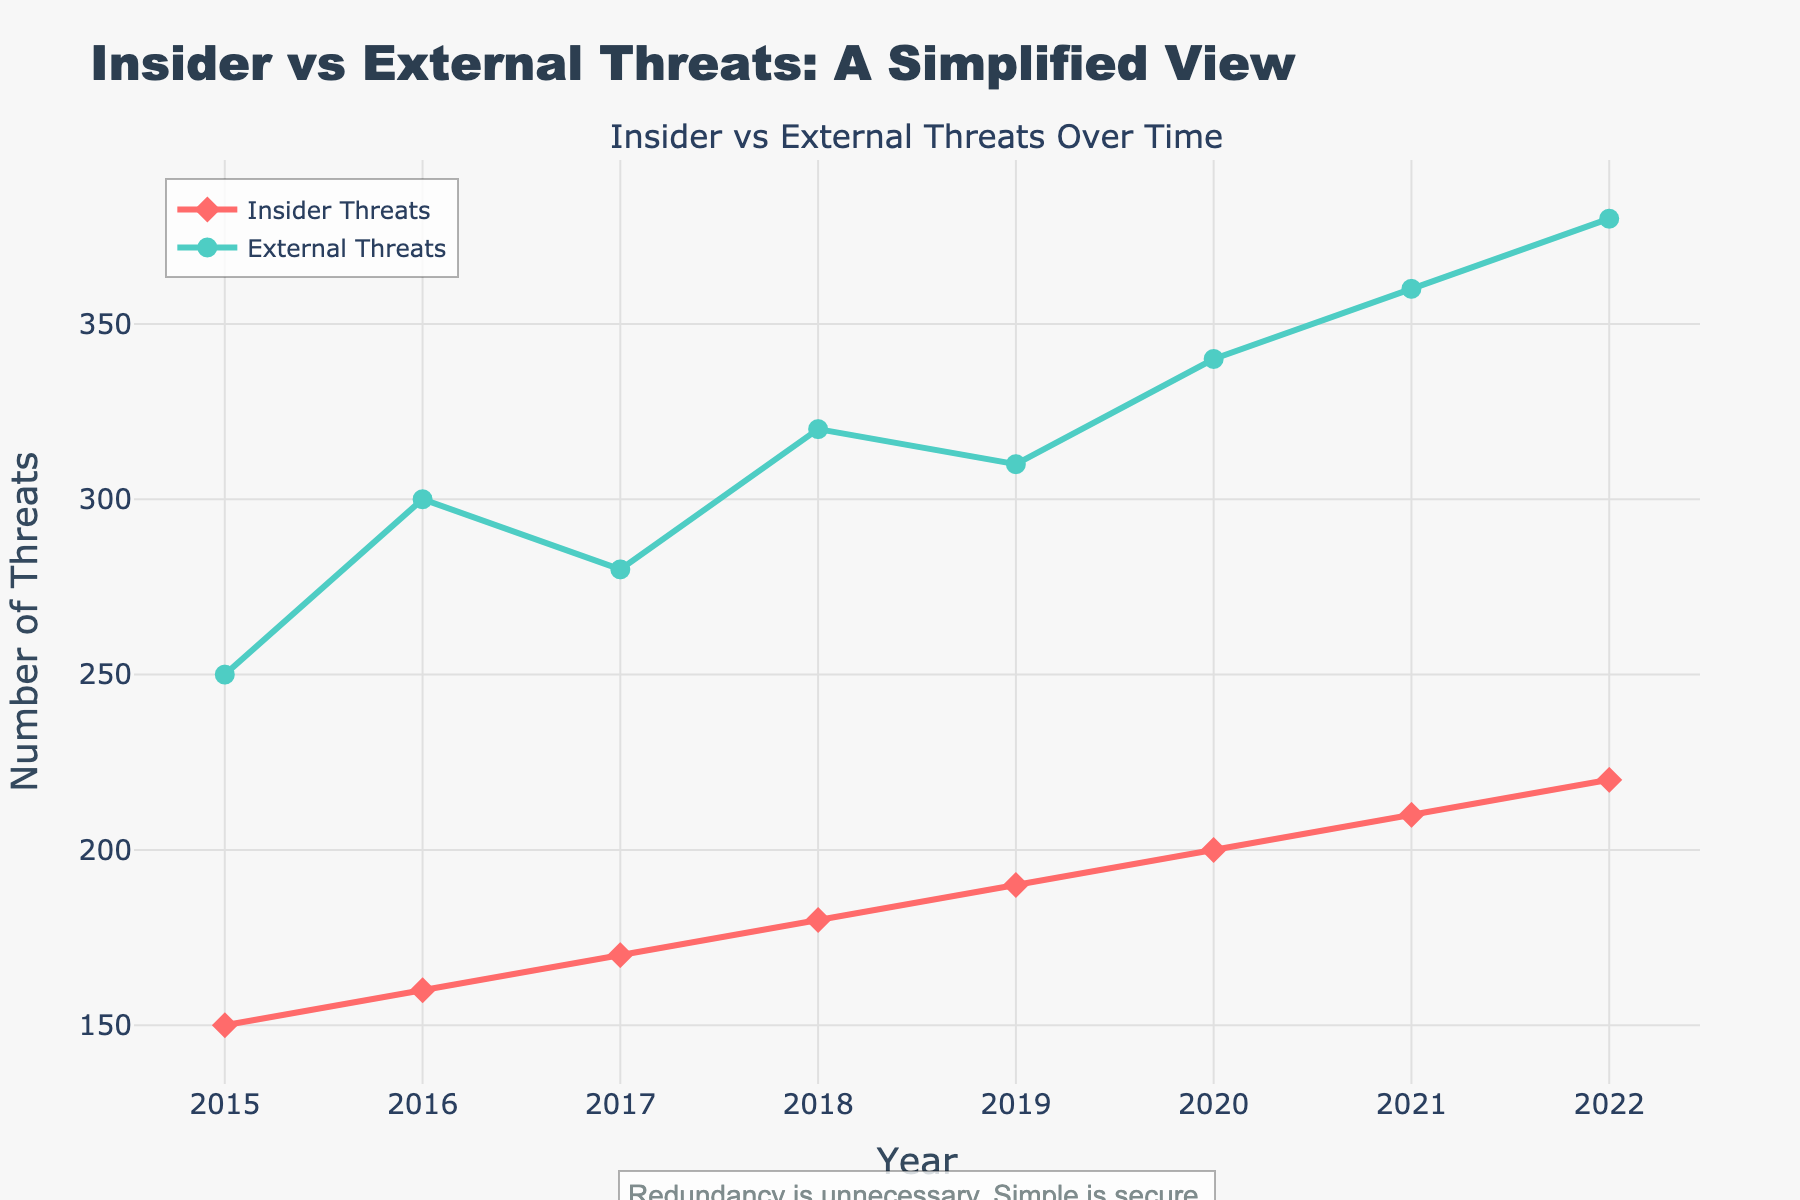What is the title of the plot? The title is displayed at the top of the plot. It reads "Insider vs External Threats: A Simplified View".
Answer: Insider vs External Threats: A Simplified View What are the two types of threats shown in the plot? This can be determined from the legend or the labels for each line. They are "Insider Threats" and "External Threats".
Answer: Insider Threats, External Threats How did the number of external threats change from 2018 to 2022? Locate the points for external threats in 2018 and 2022. In 2018, the number of external threats is 320, and in 2022 it is 380. The change can be calculated by subtracting 320 from 380.
Answer: Increase by 60 Which year had the highest number of insider threats? Look at the y-values of the "Insider Threats" line for all years. The highest point is in 2022 with 220 threats.
Answer: 2022 Which threat type had a higher incidence rate in 2020? Compare the y-values of both lines in 2020. Insider threats have 200, and external threats have 340.
Answer: External threats What is the average number of insider threats from 2015 to 2022? To calculate the average, add the number of insider threats for each year (150 + 160 + 170 + 180 + 190 + 200 + 210 + 220), then divide by 8 (the number of years).
Answer: 185 By how much did the incidence rate of insider threats increase from 2016 to 2021? Subtract the number of insider threats in 2016 (160) from the number in 2021 (210).
Answer: Increase by 50 Is there a year where the number of insider threats and external threats differ by less than 100? Calculate the difference for each year: 2015 (100), 2016 (140), 2017 (110), 2018 (140), 2019 (120), 2020 (140), 2021 (150), 2022 (160). No year meets this criterion.
Answer: No What trend is observed for external threats over the 8 years? Observe the line for external threats from 2015 to 2022. The line consistently rises, indicating an increasing trend.
Answer: Increasing trend 